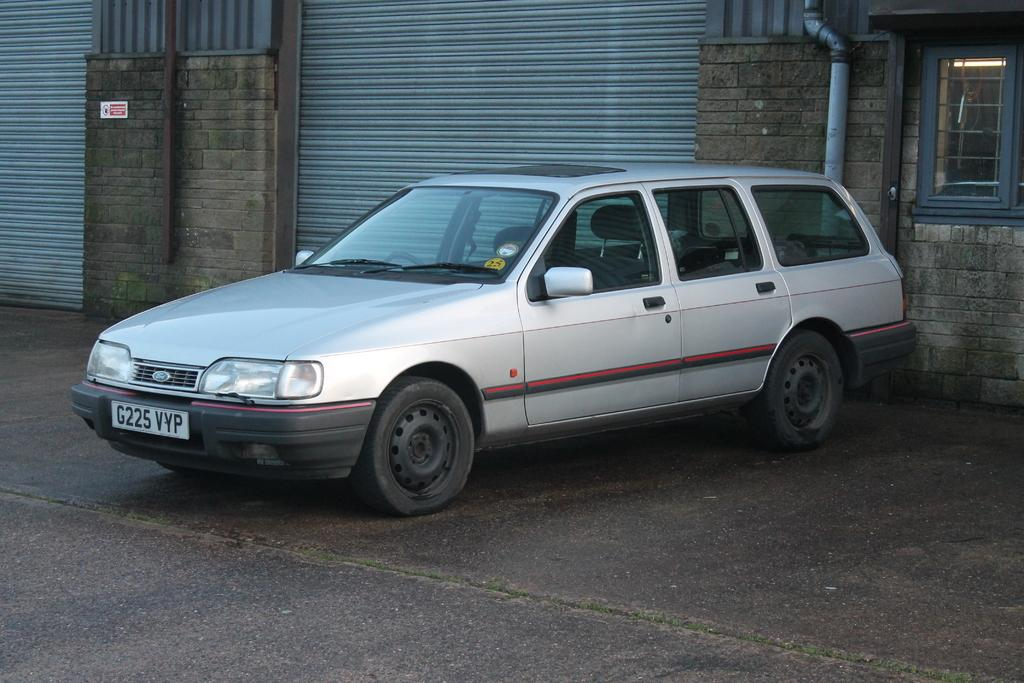What is the main subject of the image? The main subject of the image is a car on the road. What can be seen behind the car? There is a building behind the car. Can you describe any other objects in the image? There is a pipe in the image. What type of structure is visible on the right side of the image? There is a glass window on the right side of the image. Can you tell me how many rays of sunshine are visible through the glass window in the image? There is no mention of sunshine or rays in the provided facts, so it cannot be determined from the image. 